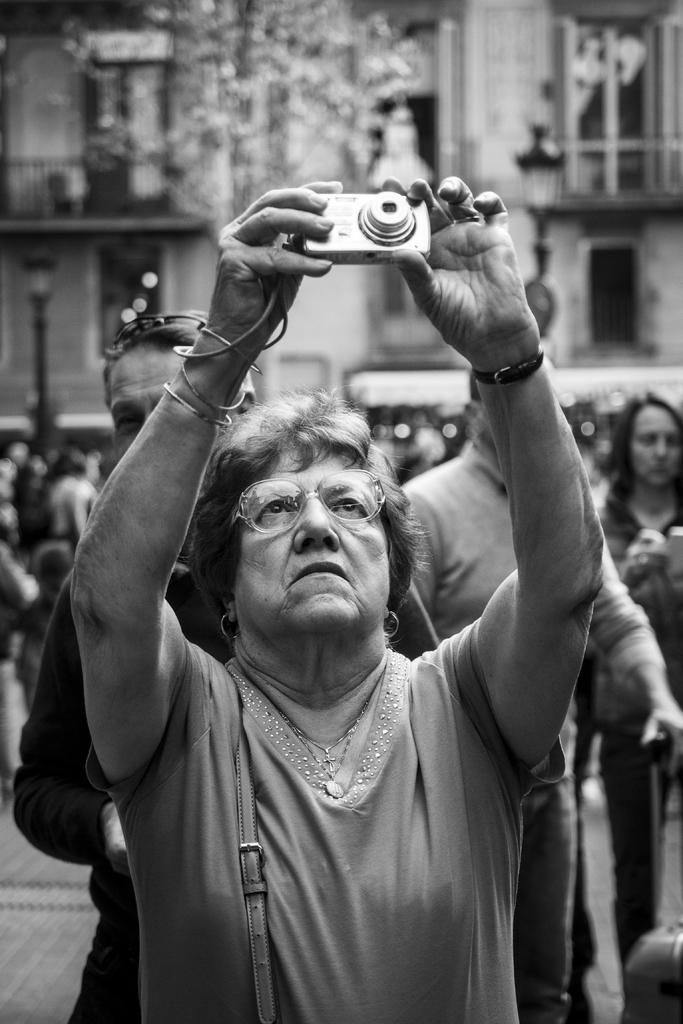How many people are in the image? There are persons standing in the image. What is one person doing in the image? One person is holding a camera. What can be seen in the background of the image? There is a building in the background of the image. What type of locket is the boy wearing in the image? There is no boy or locket present in the image. How does the person holding the camera fall in the image? There is no falling person in the image; the person holding the camera is standing. 